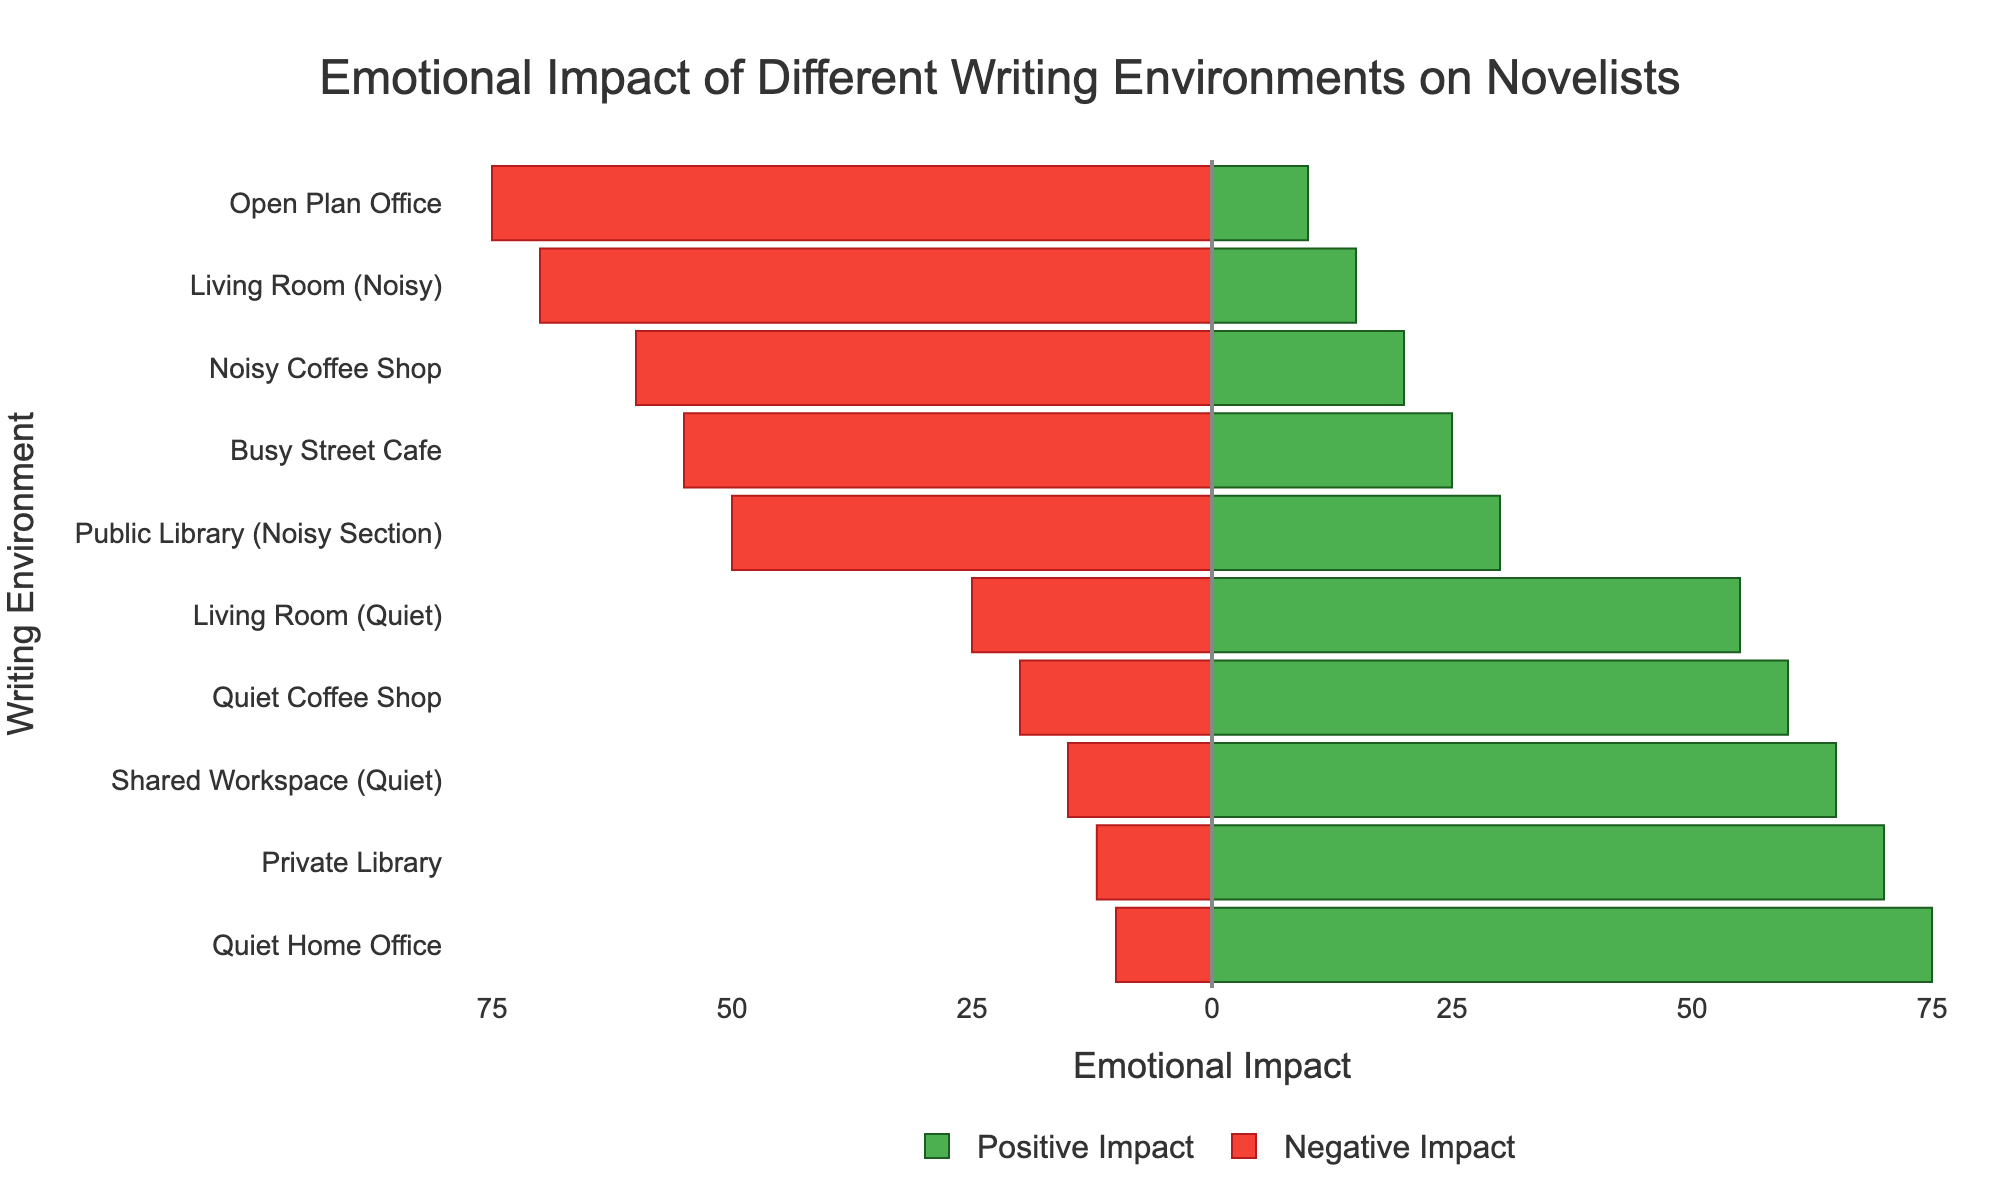Which writing environment has the highest positive emotional impact? To determine this, look at the green bars (positive impact) and find the longest one. The Quiet Home Office has the highest value of 75.
Answer: Quiet Home Office Which writing environment has the highest negative emotional impact? To determine this, look at the red bars (negative impact) and find the longest one. The Open Plan Office has the highest value of 75.
Answer: Open Plan Office Which writing environment has a greater overall emotional impact, the Quiet Home Office or the Shared Workspace (Quiet)? Sum the absolute values of the positive and negative impacts for each environment. Quiet Home Office: 75 (positive) + 10 (negative) = 85. Shared Workspace (Quiet): 65 (positive) + 15 (negative) = 80. The Quiet Home Office has a greater overall impact.
Answer: Quiet Home Office What is the total positive emotional impact across all environments? Add up all the positive impact values: 75 + 65 + 60 + 55 + 70 + 20 + 10 + 15 + 25 + 30 = 425.
Answer: 425 What is the average negative emotional impact for the noisy environments? Identify noisy environments and calculate the average negative impact. Noisy Coffee Shop: 60, Open Plan Office: 75, Living Room (Noisy): 70, Busy Street Cafe: 55, Public Library (Noisy Section): 50. (60 + 75 + 70 + 55 + 50) / 5 = 62.
Answer: 62 Which writing environment has the least positive emotional impact? Find the green bar with the shortest length. The Open Plan Office has the lowest positive impact value of 10.
Answer: Open Plan Office Which environments have more negative than positive impacts? Compare the lengths of the red and green bars for each environment. Noisy Coffee Shop, Open Plan Office, Living Room (Noisy), Busy Street Cafe, and Public Library (Noisy Section) have longer red bars than green bars.
Answer: Noisy Coffee Shop, Open Plan Office, Living Room (Noisy), Busy Street Cafe, Public Library (Noisy Section) What is the difference in the positive emotional impact between the Private Library and the Quiet Coffee Shop? Subtract the positive impact of the Quiet Coffee Shop from that of the Private Library. 70 - 60 = 10.
Answer: 10 How does the negative emotional impact of the Living Room (Noisy) compare to that of the Public Library (Noisy Section)? The negative impact for the Living Room (Noisy) is 70, and for the Public Library (Noisy Section) is 50. 70 is greater than 50.
Answer: Living Room (Noisy) has a higher negative impact Which writing environments fall within a positive emotional impact range of 25-35? Look for green bars with lengths corresponding to values between 25 and 35. The Busy Street Cafe (25) and Public Library (Noisy Section) (30) fall within this range.
Answer: Busy Street Cafe, Public Library (Noisy Section) 